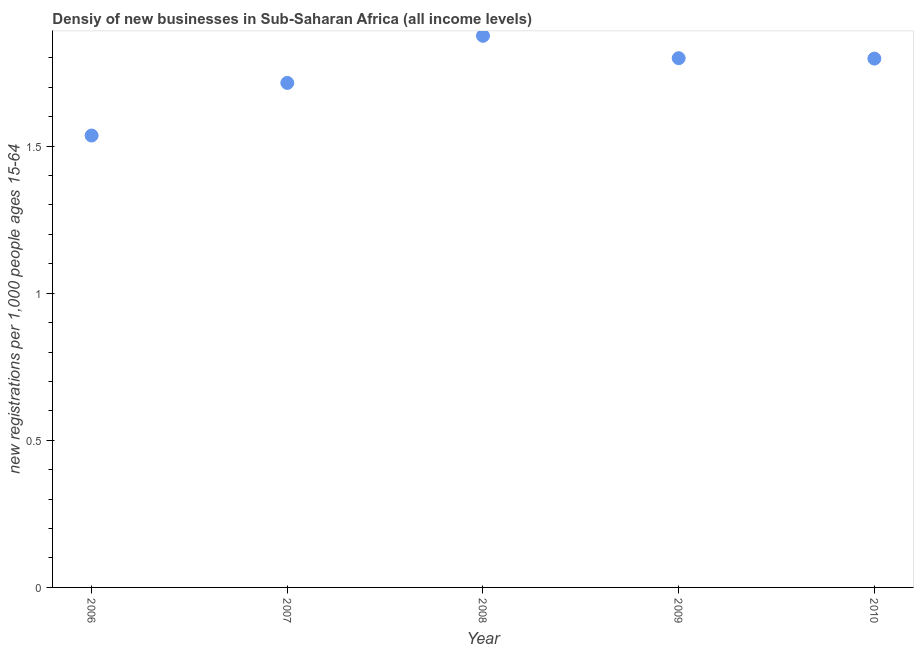What is the density of new business in 2007?
Provide a short and direct response. 1.71. Across all years, what is the maximum density of new business?
Give a very brief answer. 1.87. Across all years, what is the minimum density of new business?
Offer a terse response. 1.54. In which year was the density of new business maximum?
Your answer should be very brief. 2008. What is the sum of the density of new business?
Keep it short and to the point. 8.72. What is the difference between the density of new business in 2006 and 2010?
Your answer should be very brief. -0.26. What is the average density of new business per year?
Your answer should be compact. 1.74. What is the median density of new business?
Make the answer very short. 1.8. In how many years, is the density of new business greater than 0.6 ?
Make the answer very short. 5. Do a majority of the years between 2009 and 2008 (inclusive) have density of new business greater than 1.3 ?
Ensure brevity in your answer.  No. What is the ratio of the density of new business in 2006 to that in 2008?
Provide a succinct answer. 0.82. Is the density of new business in 2006 less than that in 2008?
Keep it short and to the point. Yes. What is the difference between the highest and the second highest density of new business?
Give a very brief answer. 0.08. What is the difference between the highest and the lowest density of new business?
Make the answer very short. 0.34. How many dotlines are there?
Your answer should be compact. 1. What is the title of the graph?
Offer a very short reply. Densiy of new businesses in Sub-Saharan Africa (all income levels). What is the label or title of the Y-axis?
Your answer should be compact. New registrations per 1,0 people ages 15-64. What is the new registrations per 1,000 people ages 15-64 in 2006?
Keep it short and to the point. 1.54. What is the new registrations per 1,000 people ages 15-64 in 2007?
Make the answer very short. 1.71. What is the new registrations per 1,000 people ages 15-64 in 2008?
Your answer should be compact. 1.87. What is the new registrations per 1,000 people ages 15-64 in 2009?
Make the answer very short. 1.8. What is the new registrations per 1,000 people ages 15-64 in 2010?
Provide a succinct answer. 1.8. What is the difference between the new registrations per 1,000 people ages 15-64 in 2006 and 2007?
Your answer should be very brief. -0.18. What is the difference between the new registrations per 1,000 people ages 15-64 in 2006 and 2008?
Offer a terse response. -0.34. What is the difference between the new registrations per 1,000 people ages 15-64 in 2006 and 2009?
Provide a short and direct response. -0.26. What is the difference between the new registrations per 1,000 people ages 15-64 in 2006 and 2010?
Make the answer very short. -0.26. What is the difference between the new registrations per 1,000 people ages 15-64 in 2007 and 2008?
Provide a succinct answer. -0.16. What is the difference between the new registrations per 1,000 people ages 15-64 in 2007 and 2009?
Keep it short and to the point. -0.08. What is the difference between the new registrations per 1,000 people ages 15-64 in 2007 and 2010?
Your answer should be very brief. -0.08. What is the difference between the new registrations per 1,000 people ages 15-64 in 2008 and 2009?
Keep it short and to the point. 0.08. What is the difference between the new registrations per 1,000 people ages 15-64 in 2008 and 2010?
Keep it short and to the point. 0.08. What is the difference between the new registrations per 1,000 people ages 15-64 in 2009 and 2010?
Offer a terse response. 0. What is the ratio of the new registrations per 1,000 people ages 15-64 in 2006 to that in 2007?
Your answer should be very brief. 0.9. What is the ratio of the new registrations per 1,000 people ages 15-64 in 2006 to that in 2008?
Your response must be concise. 0.82. What is the ratio of the new registrations per 1,000 people ages 15-64 in 2006 to that in 2009?
Your answer should be very brief. 0.85. What is the ratio of the new registrations per 1,000 people ages 15-64 in 2006 to that in 2010?
Make the answer very short. 0.85. What is the ratio of the new registrations per 1,000 people ages 15-64 in 2007 to that in 2008?
Your answer should be very brief. 0.92. What is the ratio of the new registrations per 1,000 people ages 15-64 in 2007 to that in 2009?
Your answer should be compact. 0.95. What is the ratio of the new registrations per 1,000 people ages 15-64 in 2007 to that in 2010?
Provide a succinct answer. 0.95. What is the ratio of the new registrations per 1,000 people ages 15-64 in 2008 to that in 2009?
Ensure brevity in your answer.  1.04. What is the ratio of the new registrations per 1,000 people ages 15-64 in 2008 to that in 2010?
Give a very brief answer. 1.04. 